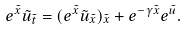Convert formula to latex. <formula><loc_0><loc_0><loc_500><loc_500>e ^ { \tilde { x } } { \tilde { u } } _ { \tilde { t } } = ( e ^ { \tilde { x } } { \tilde { u } } _ { \tilde { x } } ) _ { \tilde { x } } + e ^ { - \gamma \tilde { x } } e ^ { \tilde { u } } .</formula> 